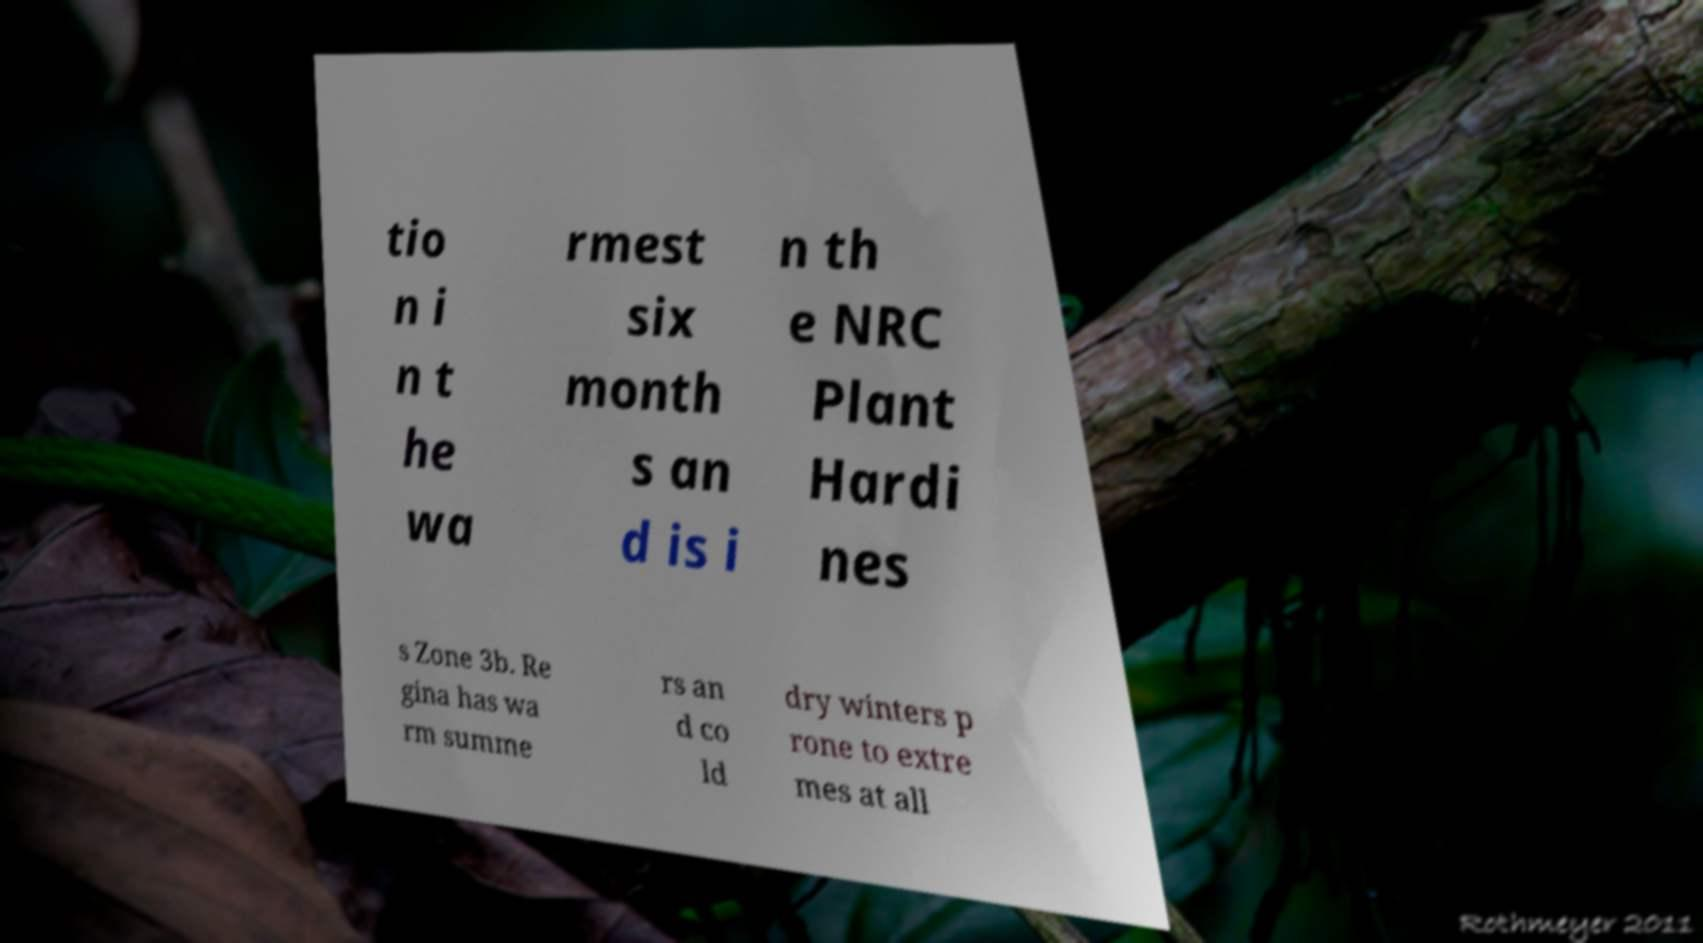Could you extract and type out the text from this image? tio n i n t he wa rmest six month s an d is i n th e NRC Plant Hardi nes s Zone 3b. Re gina has wa rm summe rs an d co ld dry winters p rone to extre mes at all 